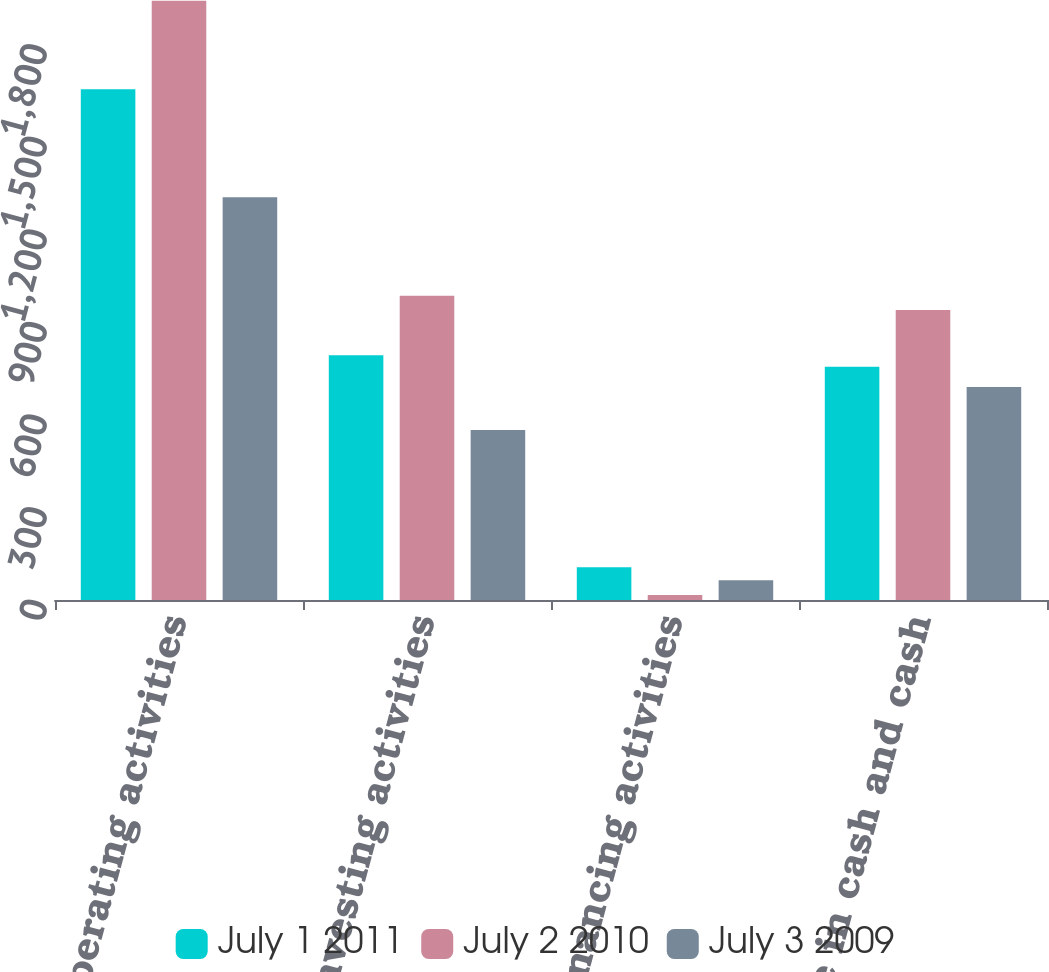Convert chart to OTSL. <chart><loc_0><loc_0><loc_500><loc_500><stacked_bar_chart><ecel><fcel>Operating activities<fcel>Investing activities<fcel>Financing activities<fcel>Net increase in cash and cash<nl><fcel>July 1 2011<fcel>1655<fcel>793<fcel>106<fcel>756<nl><fcel>July 2 2010<fcel>1942<fcel>986<fcel>16<fcel>940<nl><fcel>July 3 2009<fcel>1305<fcel>551<fcel>64<fcel>690<nl></chart> 